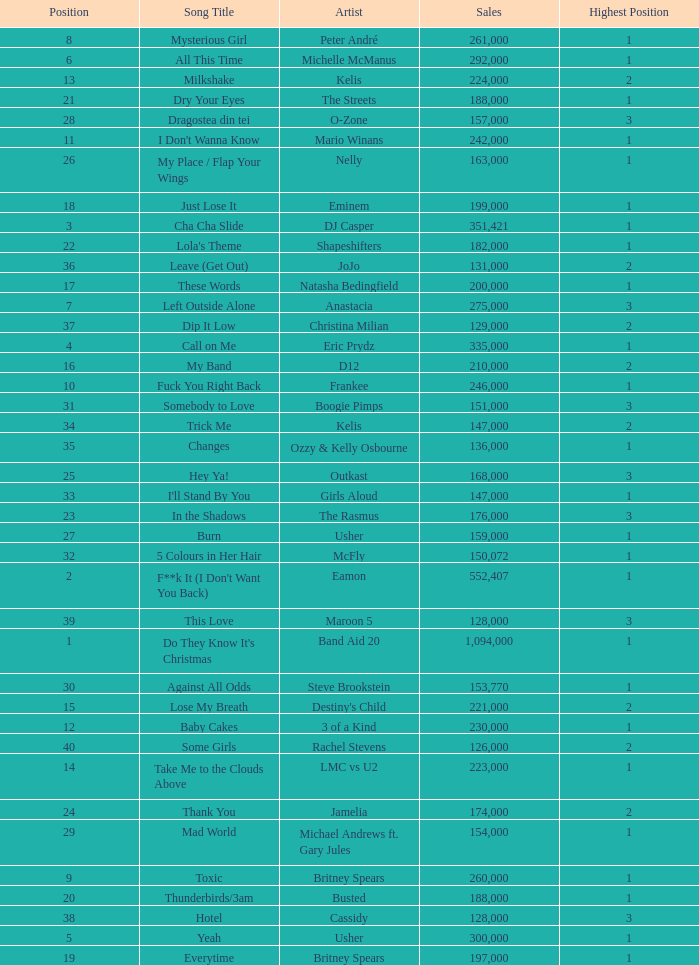What were the sales for Dj Casper when he was in a position lower than 13? 351421.0. 